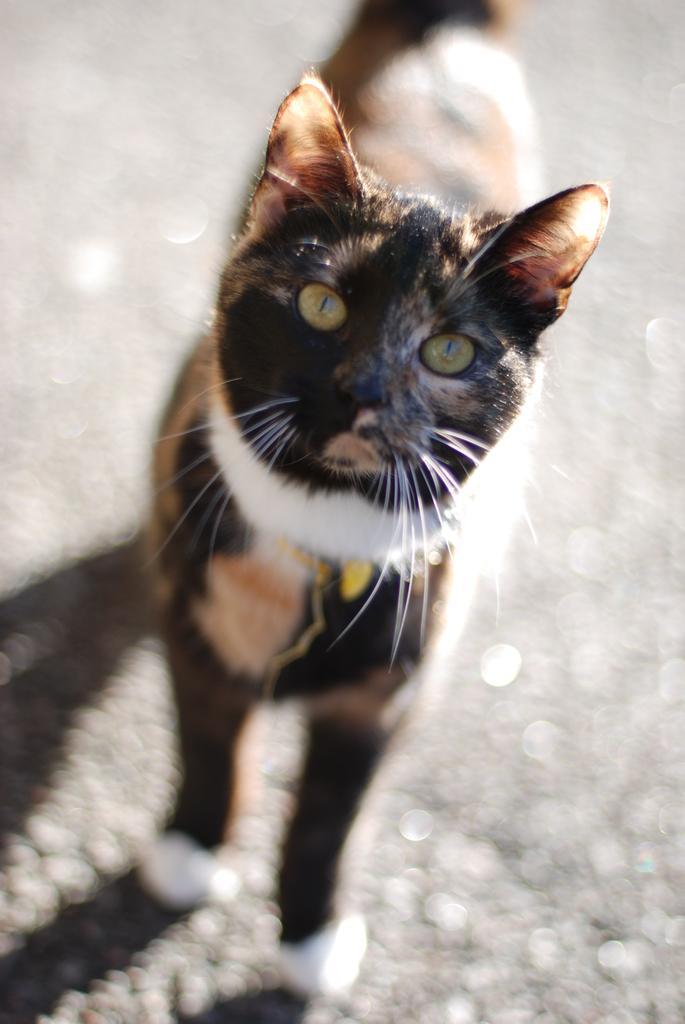Could you give a brief overview of what you see in this image? In this picture there is a cat standing. At the bottom it's looks like a man and the cat is in brown, black and in white color. 